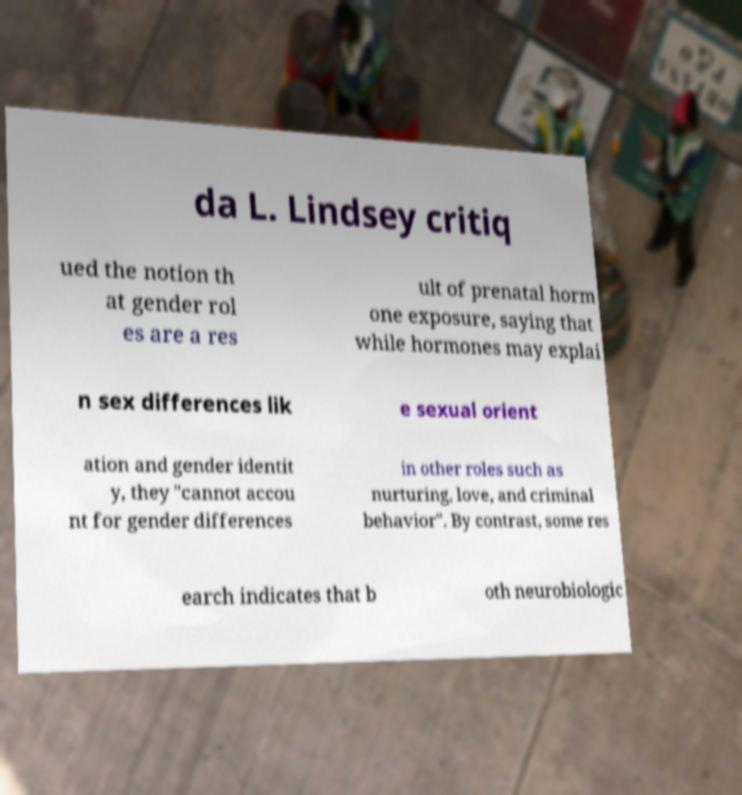For documentation purposes, I need the text within this image transcribed. Could you provide that? da L. Lindsey critiq ued the notion th at gender rol es are a res ult of prenatal horm one exposure, saying that while hormones may explai n sex differences lik e sexual orient ation and gender identit y, they "cannot accou nt for gender differences in other roles such as nurturing, love, and criminal behavior". By contrast, some res earch indicates that b oth neurobiologic 